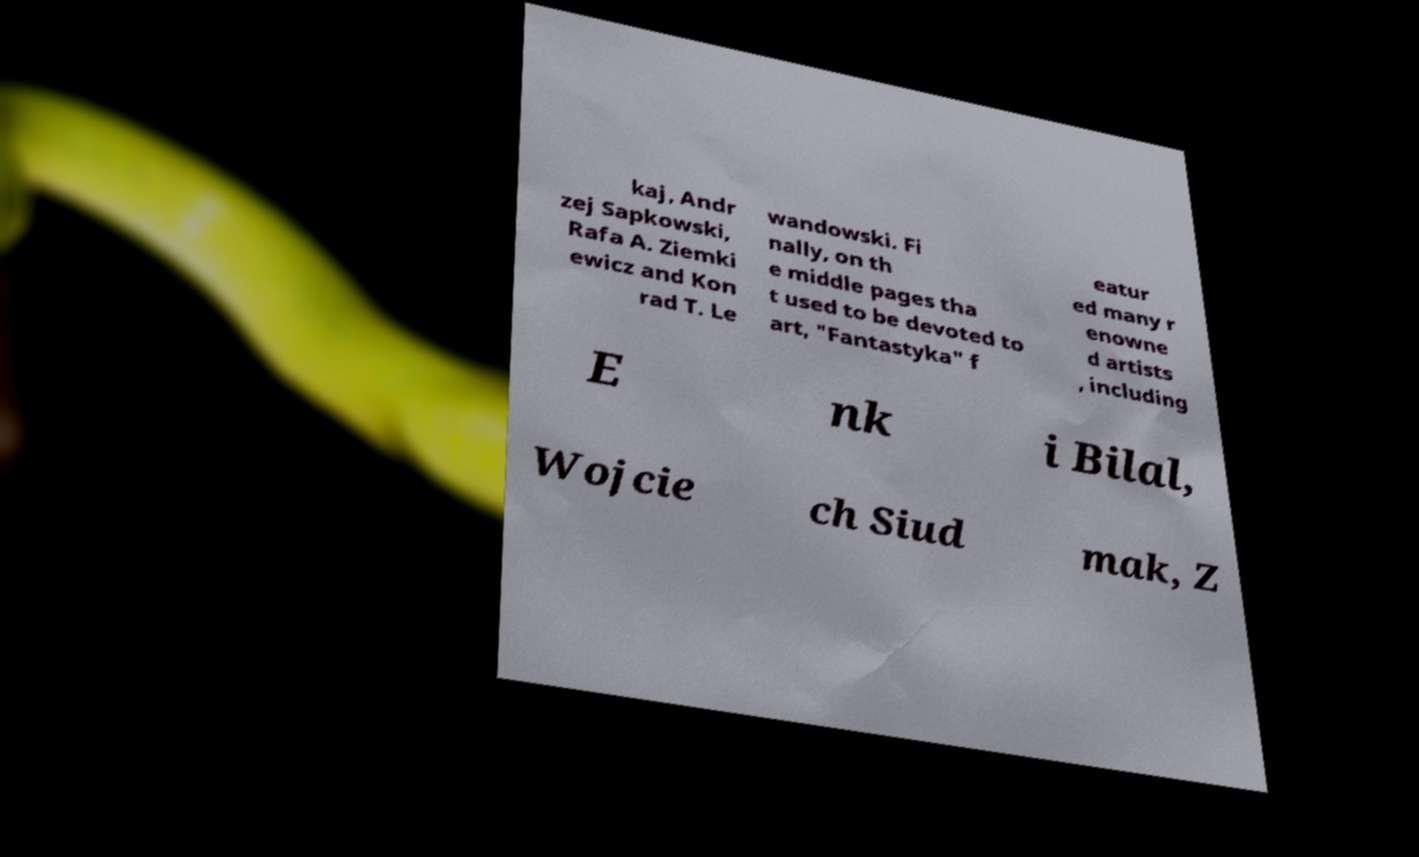I need the written content from this picture converted into text. Can you do that? kaj, Andr zej Sapkowski, Rafa A. Ziemki ewicz and Kon rad T. Le wandowski. Fi nally, on th e middle pages tha t used to be devoted to art, "Fantastyka" f eatur ed many r enowne d artists , including E nk i Bilal, Wojcie ch Siud mak, Z 